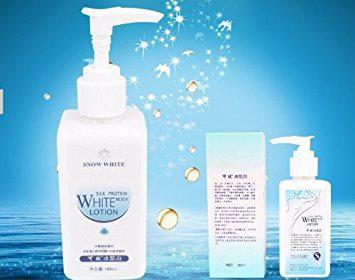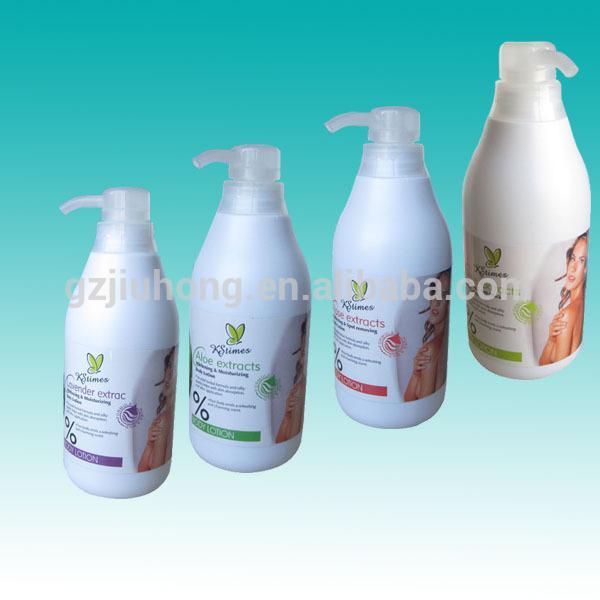The first image is the image on the left, the second image is the image on the right. Examine the images to the left and right. Is the description "The right image shows an angled row of at least three lotion products." accurate? Answer yes or no. Yes. 